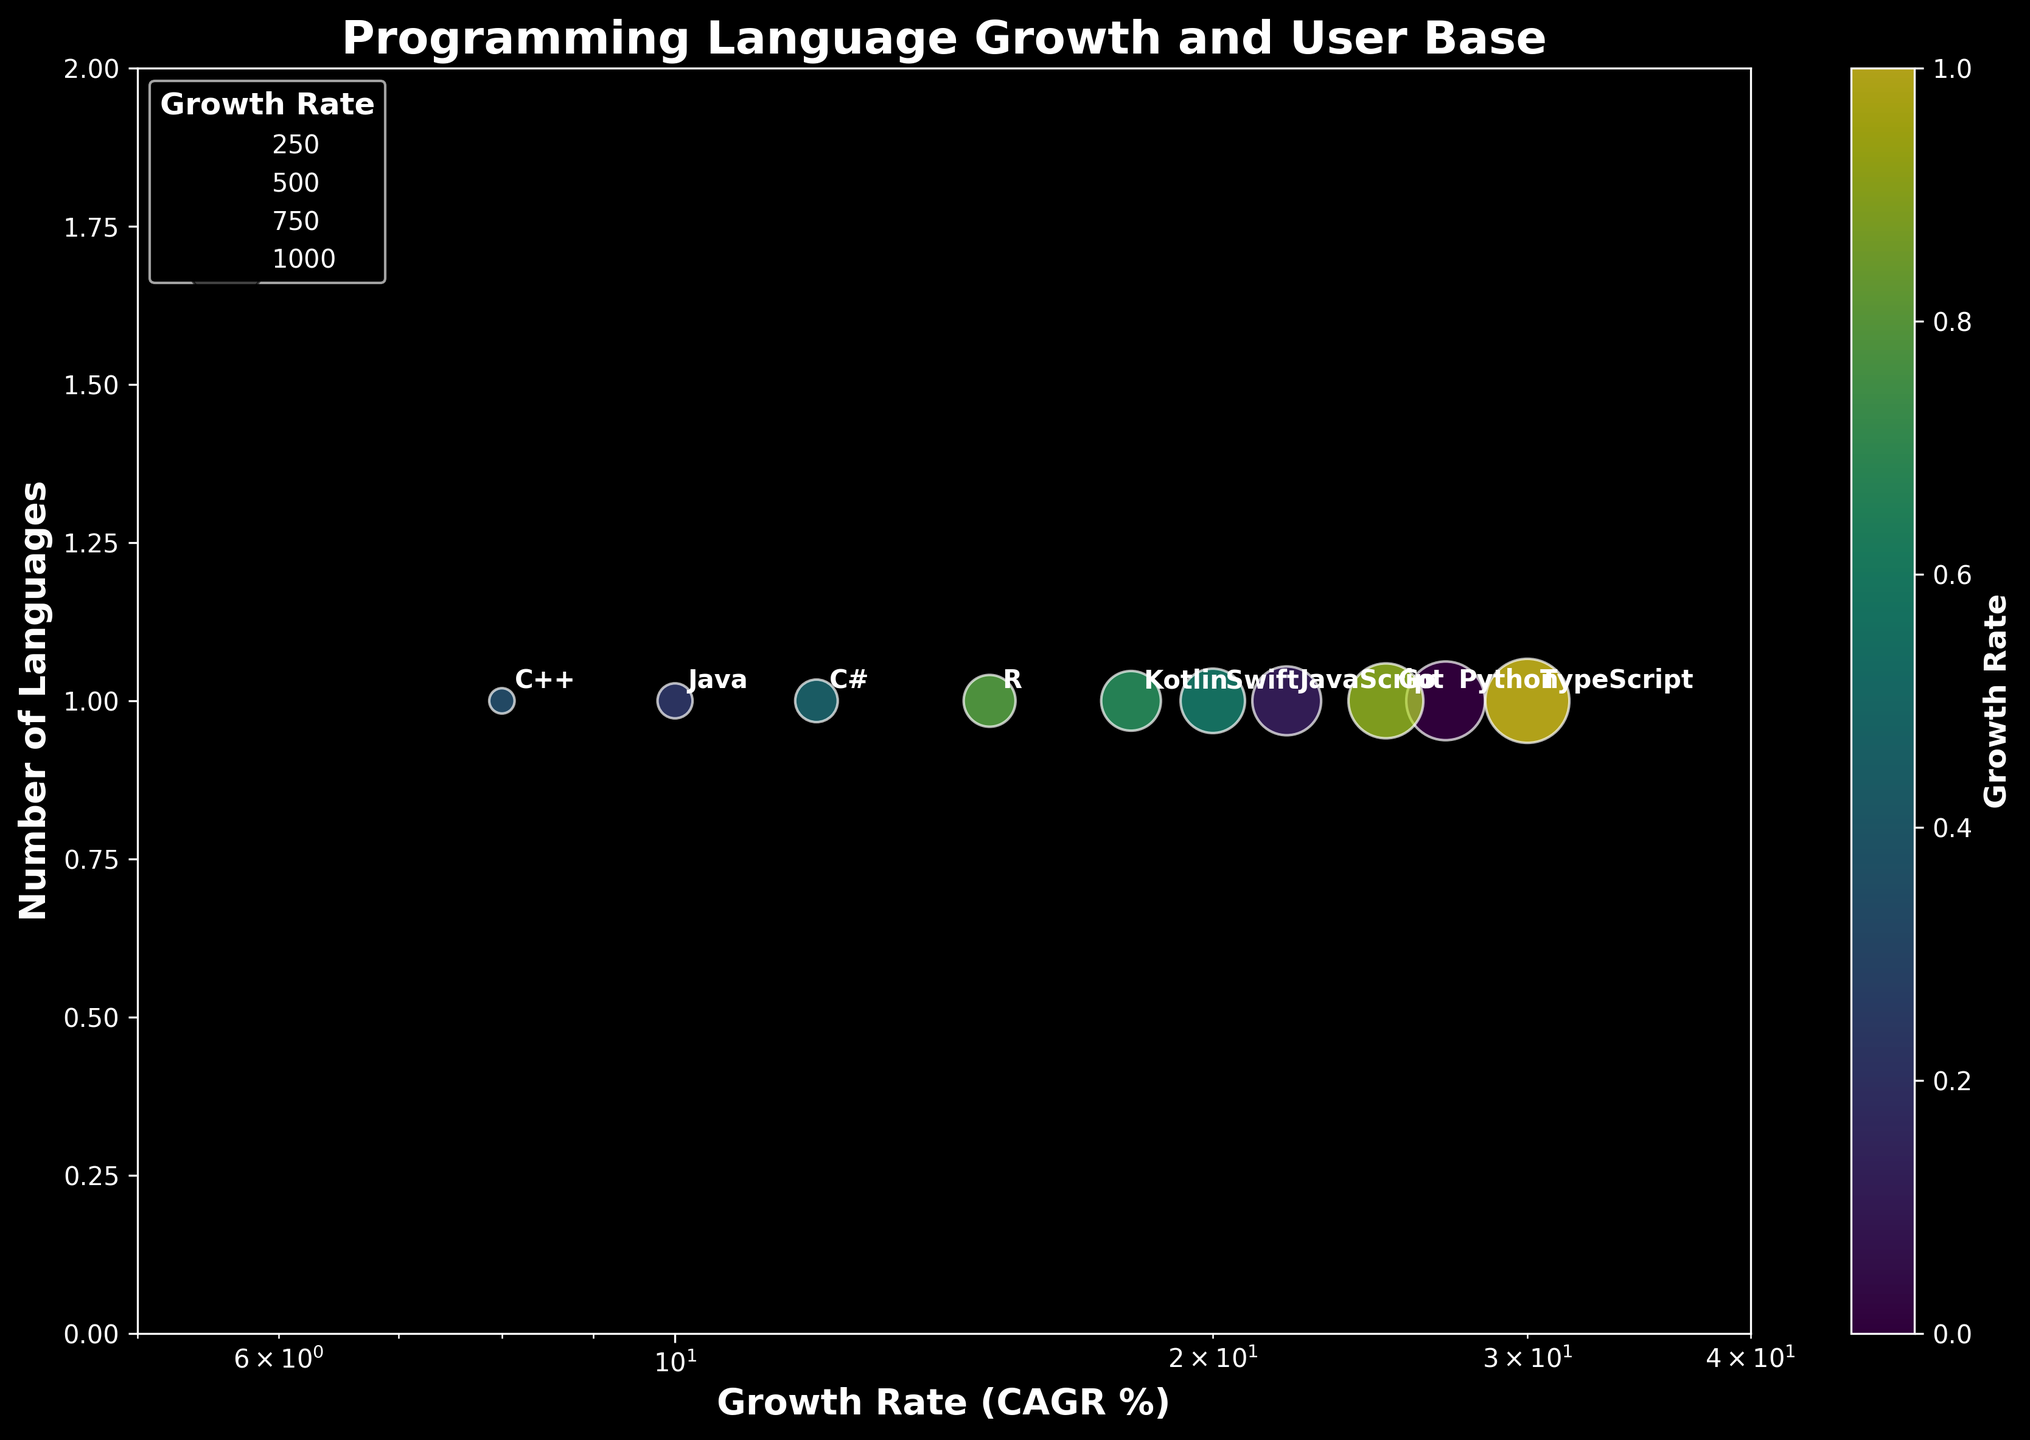What is the title of the figure? The title of the figure is displayed at the top, typically in bold and larger font compared to other texts.
Answer: Programming Language Growth and User Base What is the range of the x-axis (Growth Rate)? The x-axis range can be determined by looking at the labels at the bottom of the scatter plot, from left to right. The plot shows the range spanning from 5 to 40, and since the scale is logarithmic, these values are represented accordingly.
Answer: 5 to 40 What user base is associated with the highest growth rate? Look for the highest value on the x-axis (Growth Rate) and identify the corresponding user base label next to the data point.
Answer: Frontend Developers How many different user bases are represented in the figure? Each unique entry on the y-axis represents a different user base. Count these unique labels.
Answer: 9 Which programming language has a growth rate closest to 10%? Identify the point on the x-axis closest to 10% and check the corresponding label next to it.
Answer: Java What is the difference in growth rate between Python and C++? Locate Python and C++ on the x-axis, identify their Growth Rates, then subtract the Growth Rate of C++ from that of Python. Python has 27% and C++ has 8%. The difference is 27 - 8 = 19.
Answer: 19% How do the bubble sizes relate to the Growth Rate? Larger bubble sizes indicate a higher growth rate. Inspect the size of the bubbles and note that bigger circles correspond to languages with higher growth rates.
Answer: Higher growth rate equates to larger bubbles Which programming language has the second highest growth rate? Locate the second largest value on the x-axis and identify the corresponding programming language label next to it.
Answer: Python How are the colors of the bubbles determined? Colors follow a gradient with respect to the Growth Rate. The viridis color map indicates that colors transition as the Growth Rate increases. Inspecting the gradient shows this correlation.
Answer: Based on the Growth Rate What is the dominant user base of the programming language with the 15% growth rate? Locate the 15% mark on the x-axis and find the corresponding data point. Check the label next to it for the dominant user base.
Answer: Statisticians 